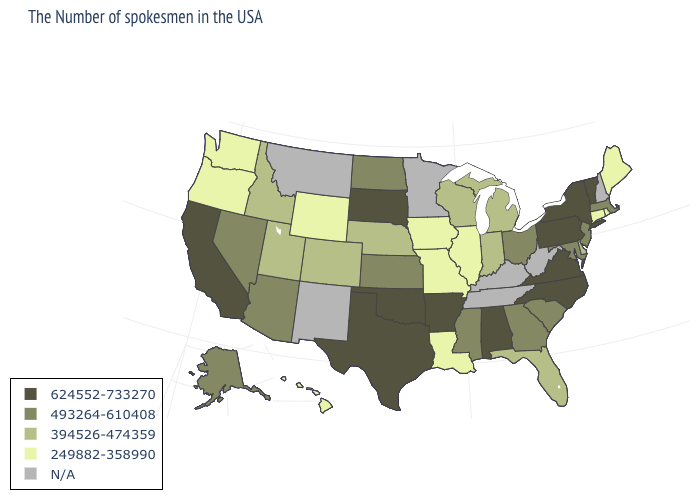Which states have the lowest value in the USA?
Short answer required. Maine, Rhode Island, Connecticut, Illinois, Louisiana, Missouri, Iowa, Wyoming, Washington, Oregon, Hawaii. What is the value of North Dakota?
Write a very short answer. 493264-610408. What is the value of Montana?
Give a very brief answer. N/A. Does the first symbol in the legend represent the smallest category?
Quick response, please. No. Name the states that have a value in the range 624552-733270?
Give a very brief answer. Vermont, New York, Pennsylvania, Virginia, North Carolina, Alabama, Arkansas, Oklahoma, Texas, South Dakota, California. How many symbols are there in the legend?
Give a very brief answer. 5. What is the value of Rhode Island?
Keep it brief. 249882-358990. Does the first symbol in the legend represent the smallest category?
Concise answer only. No. Which states hav the highest value in the West?
Write a very short answer. California. Among the states that border Michigan , does Indiana have the lowest value?
Give a very brief answer. Yes. How many symbols are there in the legend?
Write a very short answer. 5. Name the states that have a value in the range N/A?
Answer briefly. New Hampshire, West Virginia, Kentucky, Tennessee, Minnesota, New Mexico, Montana. Does Vermont have the highest value in the USA?
Give a very brief answer. Yes. Does Texas have the highest value in the USA?
Concise answer only. Yes. Among the states that border Nevada , which have the highest value?
Short answer required. California. 